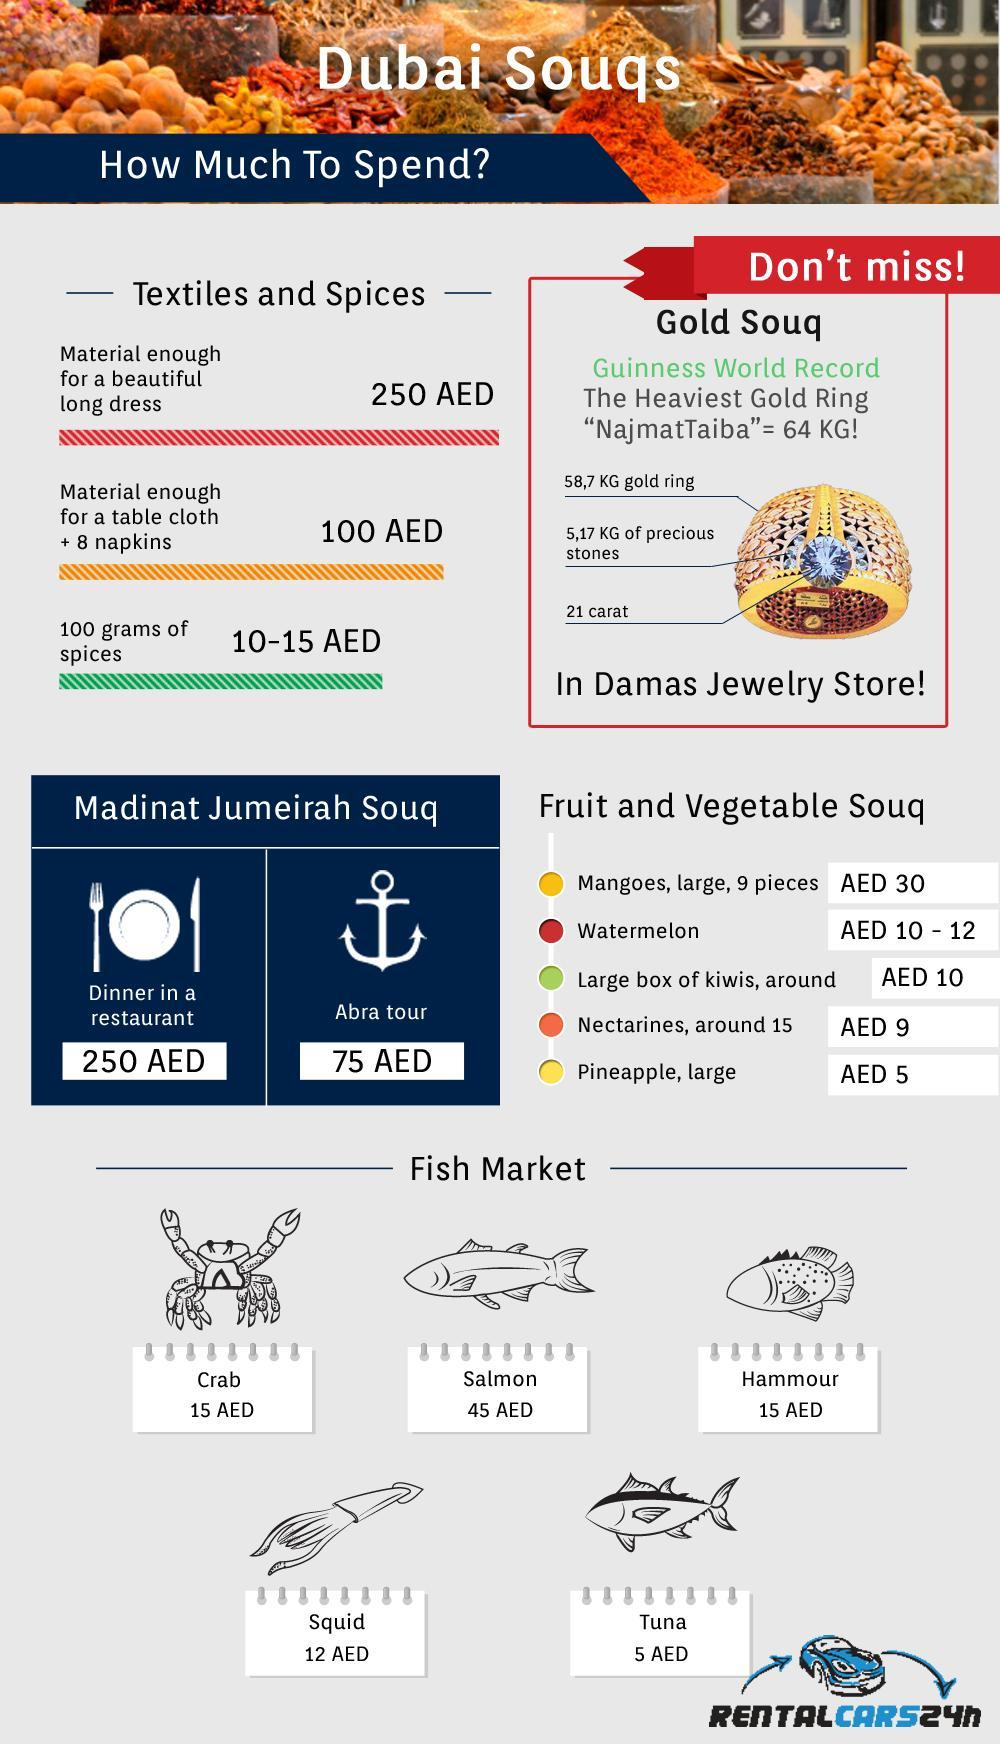Which fish costs high in the fish market at Dubai souq?
Answer the question with a short phrase. Salmon What is the cost of Hammour in the fish market at Dubai souq? 15 AED How much it costs for a abra tour at Madinat Jumeirah Souq in Dubai? 75 AED What is the cost of Tuna in the fish market at Dubai souq? 5 AED What quantity of precious stones are embedded in "NajmatTaiba"- the heaviest gold ring? 5.17 KG What does a dinner in a restaurant costs at Madinat Jumeirah Souq in Dubai? 250 AED 